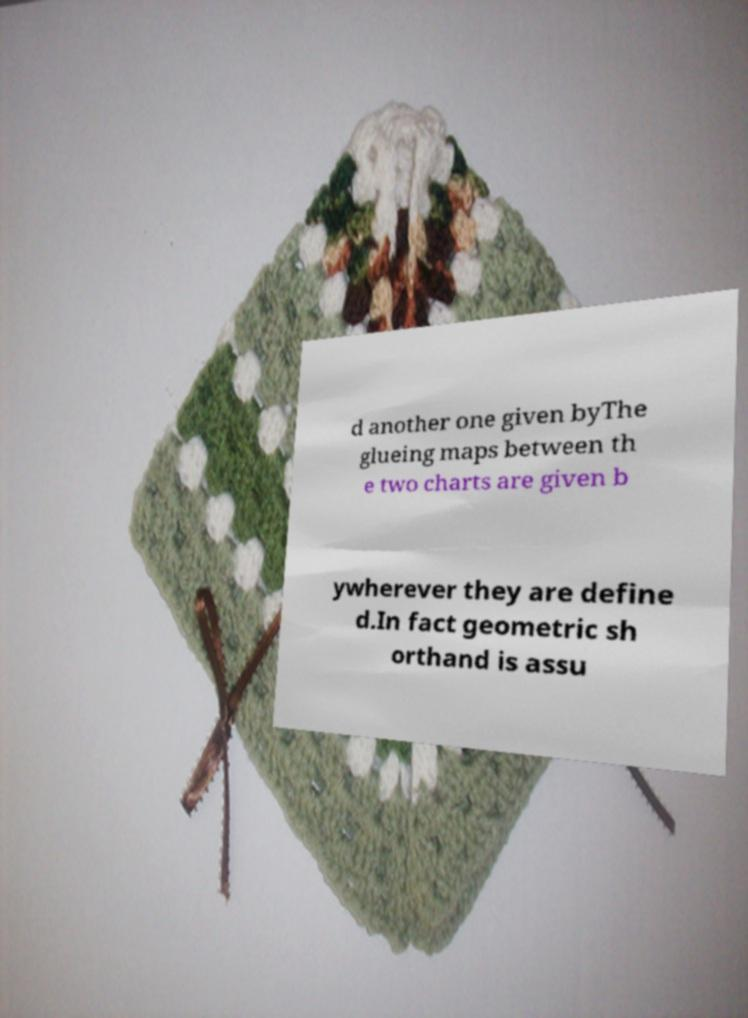I need the written content from this picture converted into text. Can you do that? d another one given byThe glueing maps between th e two charts are given b ywherever they are define d.In fact geometric sh orthand is assu 